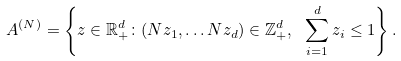<formula> <loc_0><loc_0><loc_500><loc_500>A ^ { ( N ) } = \left \{ z \in \mathbb { R } ^ { d } _ { + } \colon ( N z _ { 1 } , \dots N z _ { d } ) \in \mathbb { Z } ^ { d } _ { + } , \ \sum _ { i = 1 } ^ { d } z _ { i } \leq 1 \right \} .</formula> 